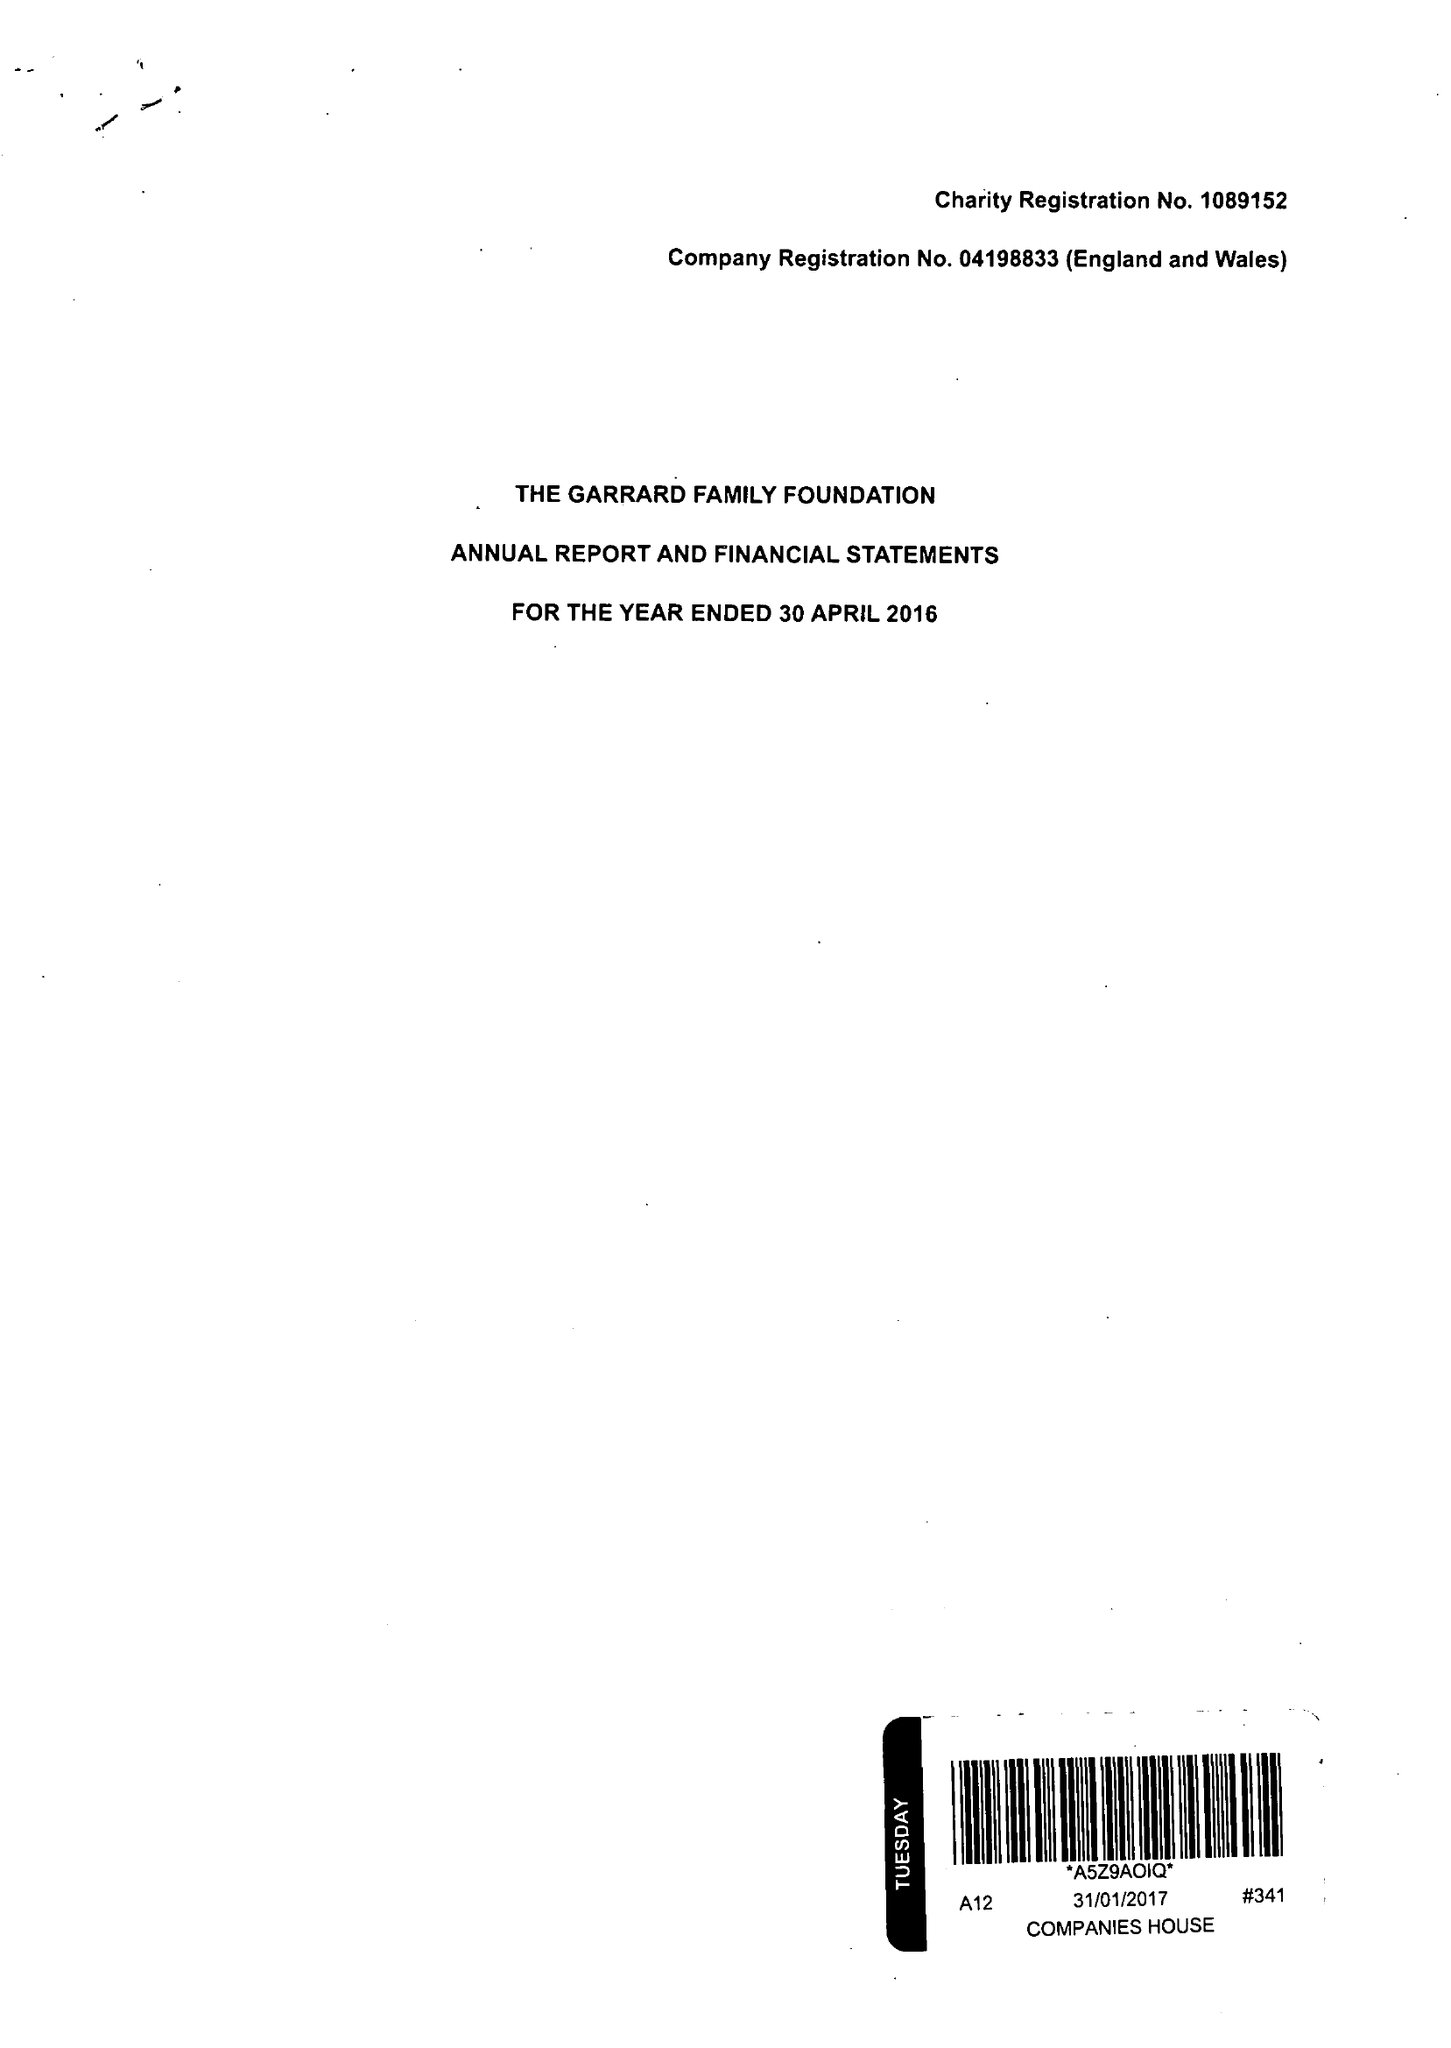What is the value for the address__postcode?
Answer the question using a single word or phrase. EC3V 3QQ 